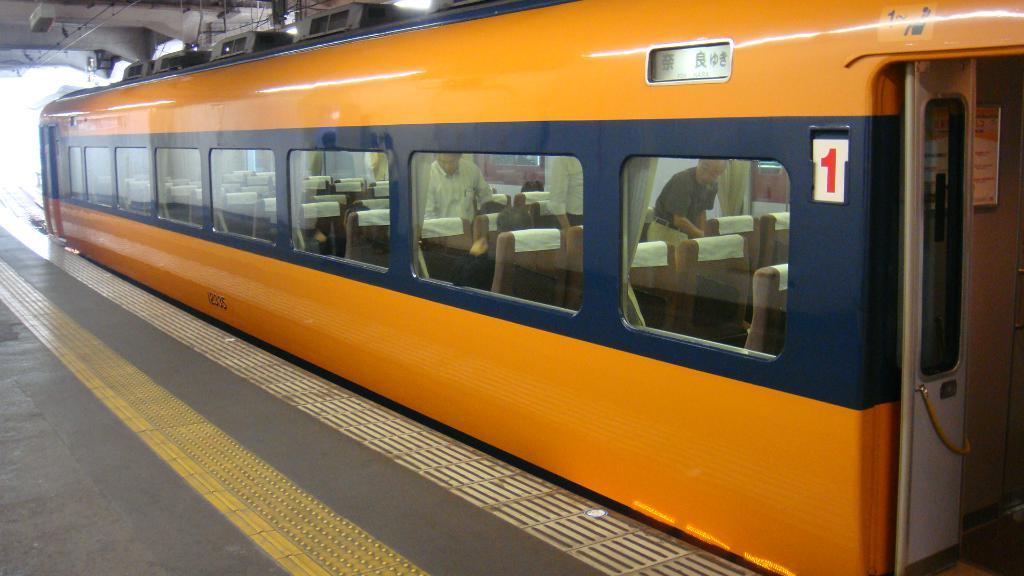What is the main subject of the picture? The main subject of the picture is a train. Can you describe what is happening inside the train? People are visible through the window glasses, suggesting that they are passengers inside the train. What feature of the train is visible in the image? There is a door in the image. What is the train's location in the image? The train is on a platform, which is also visible in the image. What type of verse can be heard being recited by the creature in the image? There is no creature or verse present in the image; it features a train on a platform with passengers inside. What color is the chalk used to draw on the platform in the image? There is no chalk or drawing present on the platform in the image. 